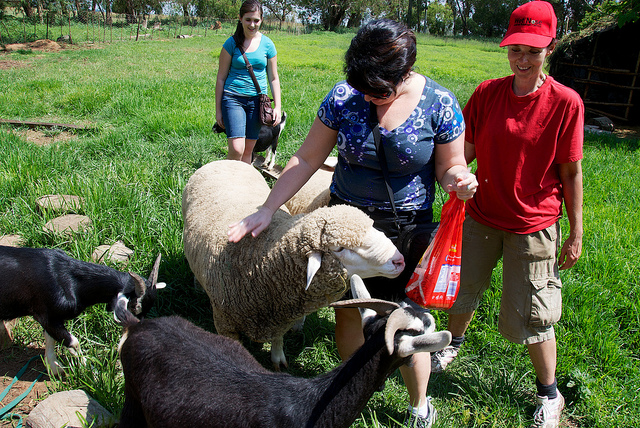Can you describe the overall mood and atmosphere of the scene? The overall mood of the scene appears to be cheerful and relaxed. The people are engaging with the animals, and the animals seem comfortable and unbothered by their presence. The vibrant green of the pasture and the bright blue sky also contribute to a pleasant, idyllic atmosphere. What can you infer about the relationship between the people and animals? The relationship between the people and the animals seems to be one of mutual trust and comfort. The animals appear relaxed and allow themselves to be petted, indicating they are accustomed to human interaction. The people, in turn, seem to enjoy the animals' company, suggesting a sense of harmony and connection with them. Imagine what might happen next in this scene. Next in this scene, the woman with the plastic bag might pull out food or treats for the animals, creating even more interaction. The other two individuals might join in, either taking photos or helping with the feeding. This interaction could further increase the cheerful mood of the scene, potentially leading to more bonding time between the people and the animals. Let's get creative: What if these animals had a secret civilization we couldn't see? In a secret civilization hidden beneath the lush green grass, the sheep rule as wise elders while the goats act as adventurous explorers. These animals live in intricately designed burrows, complete with tunnels lined with moss and algae for comfort. They hold nightly councils illuminated by bioluminescent fungi and discuss plans for protecting their pasture home. The sheep maintain historical records on stone tablets, while the goats experiment with natural remedies and forage for unique herbs. When humans visit, they carefully observe, ensuring their secret remains hidden. Perhaps, one day, they might reveal their existence to a kind-hearted human who demonstrates genuine love and care for their well-being. Can you describe a realistic scenario where items typical to a farm setting might be present in the image? In a realistic farm setting, you might see various tools and equipment scattered around the scene. There could be a wheelbarrow filled with hay, a bucket for feeding or watering the animals, and perhaps a pair of gardening gloves or a rake leaning against a fence. These items would help indicate an active and well-maintained farm, showing the hard work that goes into caring for the animals and the land. Describe a different potential interaction scene with these animals. In another potential interaction scene, the woman in the blue top might sit on the grass, with the sheep and goats surrounding her. She carefully spreads out some grain or vegetable pieces from her plastic bag, and the animals eagerly nibble at the food, their gentle munching sounds creating a serene ambiance. The other two people could engage in setting up a small picnic or taking scenic photos of the surroundings, capturing the tranquility of this peaceful farm moment. 